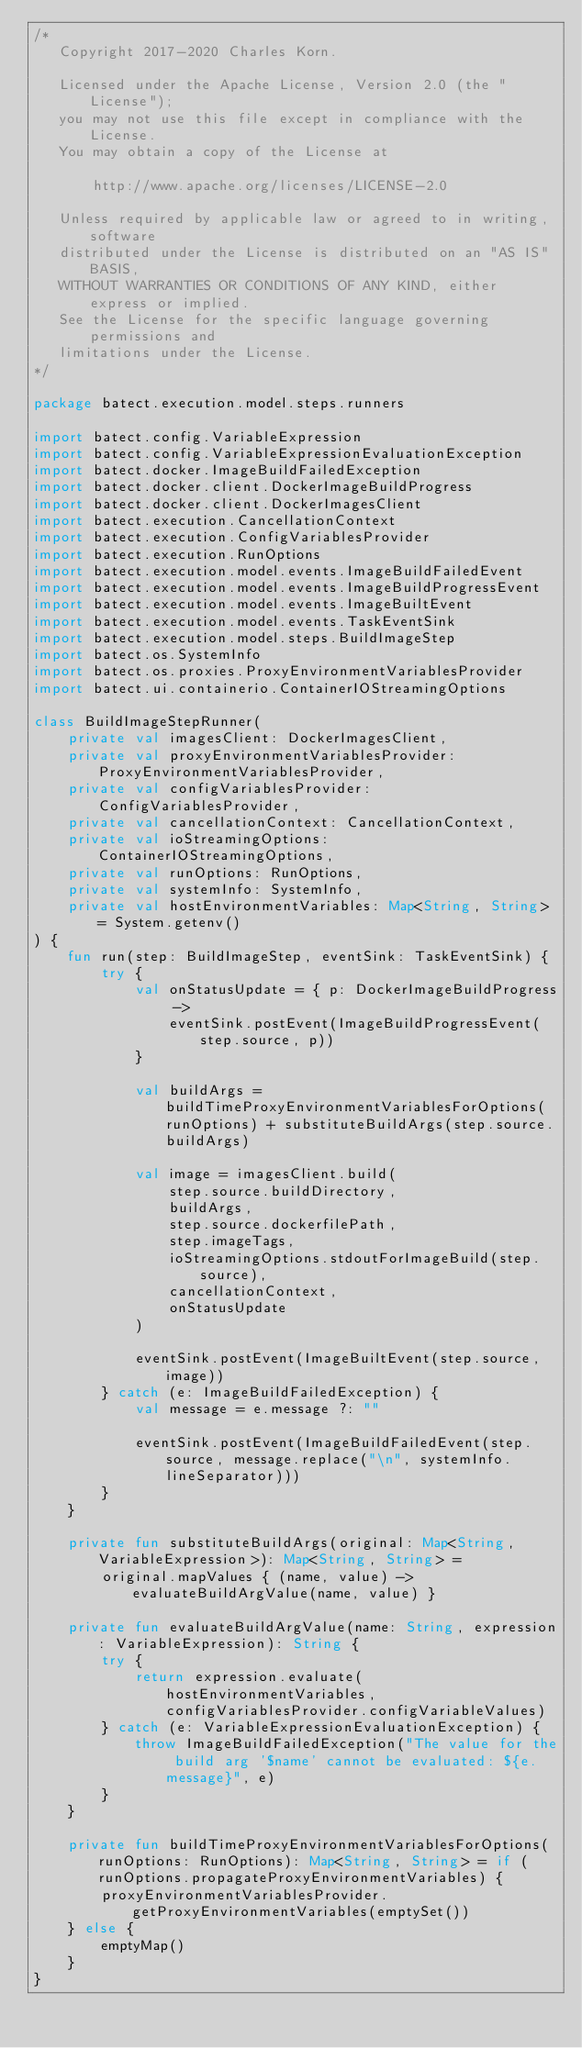<code> <loc_0><loc_0><loc_500><loc_500><_Kotlin_>/*
   Copyright 2017-2020 Charles Korn.

   Licensed under the Apache License, Version 2.0 (the "License");
   you may not use this file except in compliance with the License.
   You may obtain a copy of the License at

       http://www.apache.org/licenses/LICENSE-2.0

   Unless required by applicable law or agreed to in writing, software
   distributed under the License is distributed on an "AS IS" BASIS,
   WITHOUT WARRANTIES OR CONDITIONS OF ANY KIND, either express or implied.
   See the License for the specific language governing permissions and
   limitations under the License.
*/

package batect.execution.model.steps.runners

import batect.config.VariableExpression
import batect.config.VariableExpressionEvaluationException
import batect.docker.ImageBuildFailedException
import batect.docker.client.DockerImageBuildProgress
import batect.docker.client.DockerImagesClient
import batect.execution.CancellationContext
import batect.execution.ConfigVariablesProvider
import batect.execution.RunOptions
import batect.execution.model.events.ImageBuildFailedEvent
import batect.execution.model.events.ImageBuildProgressEvent
import batect.execution.model.events.ImageBuiltEvent
import batect.execution.model.events.TaskEventSink
import batect.execution.model.steps.BuildImageStep
import batect.os.SystemInfo
import batect.os.proxies.ProxyEnvironmentVariablesProvider
import batect.ui.containerio.ContainerIOStreamingOptions

class BuildImageStepRunner(
    private val imagesClient: DockerImagesClient,
    private val proxyEnvironmentVariablesProvider: ProxyEnvironmentVariablesProvider,
    private val configVariablesProvider: ConfigVariablesProvider,
    private val cancellationContext: CancellationContext,
    private val ioStreamingOptions: ContainerIOStreamingOptions,
    private val runOptions: RunOptions,
    private val systemInfo: SystemInfo,
    private val hostEnvironmentVariables: Map<String, String> = System.getenv()
) {
    fun run(step: BuildImageStep, eventSink: TaskEventSink) {
        try {
            val onStatusUpdate = { p: DockerImageBuildProgress ->
                eventSink.postEvent(ImageBuildProgressEvent(step.source, p))
            }

            val buildArgs = buildTimeProxyEnvironmentVariablesForOptions(runOptions) + substituteBuildArgs(step.source.buildArgs)

            val image = imagesClient.build(
                step.source.buildDirectory,
                buildArgs,
                step.source.dockerfilePath,
                step.imageTags,
                ioStreamingOptions.stdoutForImageBuild(step.source),
                cancellationContext,
                onStatusUpdate
            )

            eventSink.postEvent(ImageBuiltEvent(step.source, image))
        } catch (e: ImageBuildFailedException) {
            val message = e.message ?: ""

            eventSink.postEvent(ImageBuildFailedEvent(step.source, message.replace("\n", systemInfo.lineSeparator)))
        }
    }

    private fun substituteBuildArgs(original: Map<String, VariableExpression>): Map<String, String> =
        original.mapValues { (name, value) -> evaluateBuildArgValue(name, value) }

    private fun evaluateBuildArgValue(name: String, expression: VariableExpression): String {
        try {
            return expression.evaluate(hostEnvironmentVariables, configVariablesProvider.configVariableValues)
        } catch (e: VariableExpressionEvaluationException) {
            throw ImageBuildFailedException("The value for the build arg '$name' cannot be evaluated: ${e.message}", e)
        }
    }

    private fun buildTimeProxyEnvironmentVariablesForOptions(runOptions: RunOptions): Map<String, String> = if (runOptions.propagateProxyEnvironmentVariables) {
        proxyEnvironmentVariablesProvider.getProxyEnvironmentVariables(emptySet())
    } else {
        emptyMap()
    }
}
</code> 